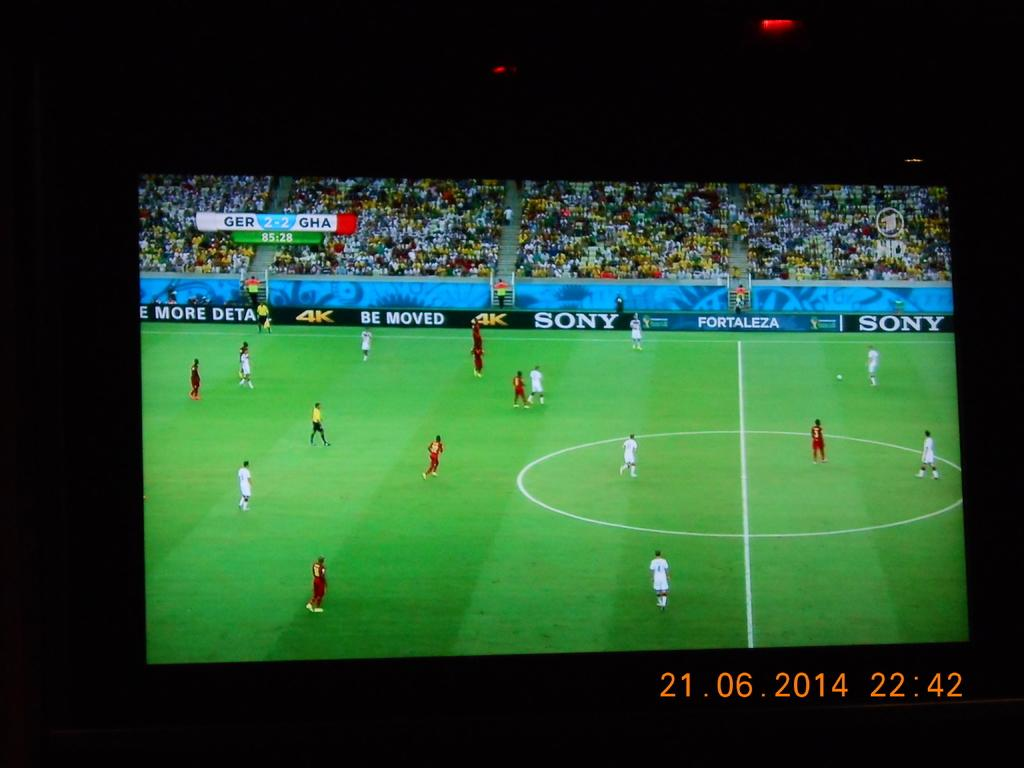<image>
Provide a brief description of the given image. A Sony advertisement is visible on the side of a soccer field. 